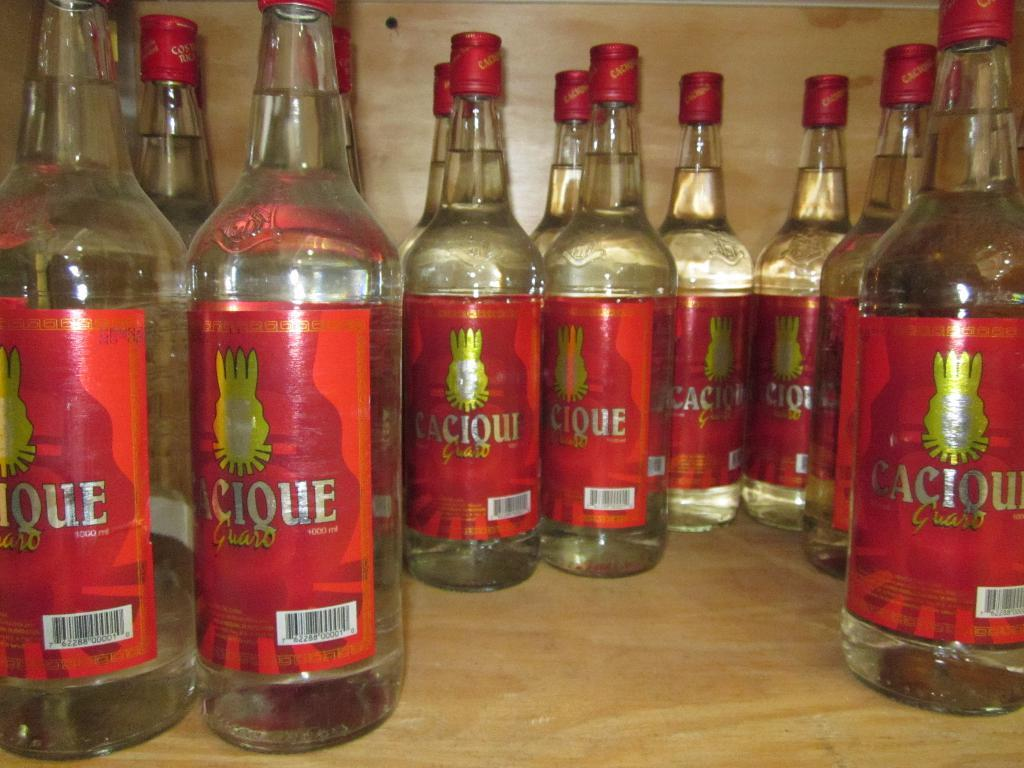Provide a one-sentence caption for the provided image. A bunch of bottles called Caciquo sit on a shelf. 